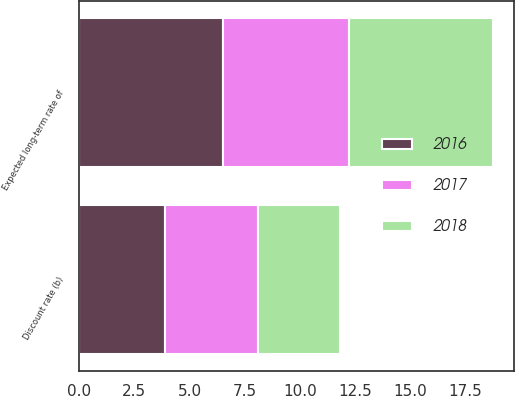Convert chart. <chart><loc_0><loc_0><loc_500><loc_500><stacked_bar_chart><ecel><fcel>Expected long-term rate of<fcel>Discount rate (b)<nl><fcel>2017<fcel>5.75<fcel>4.24<nl><fcel>2016<fcel>6.5<fcel>3.88<nl><fcel>2018<fcel>6.5<fcel>3.72<nl></chart> 